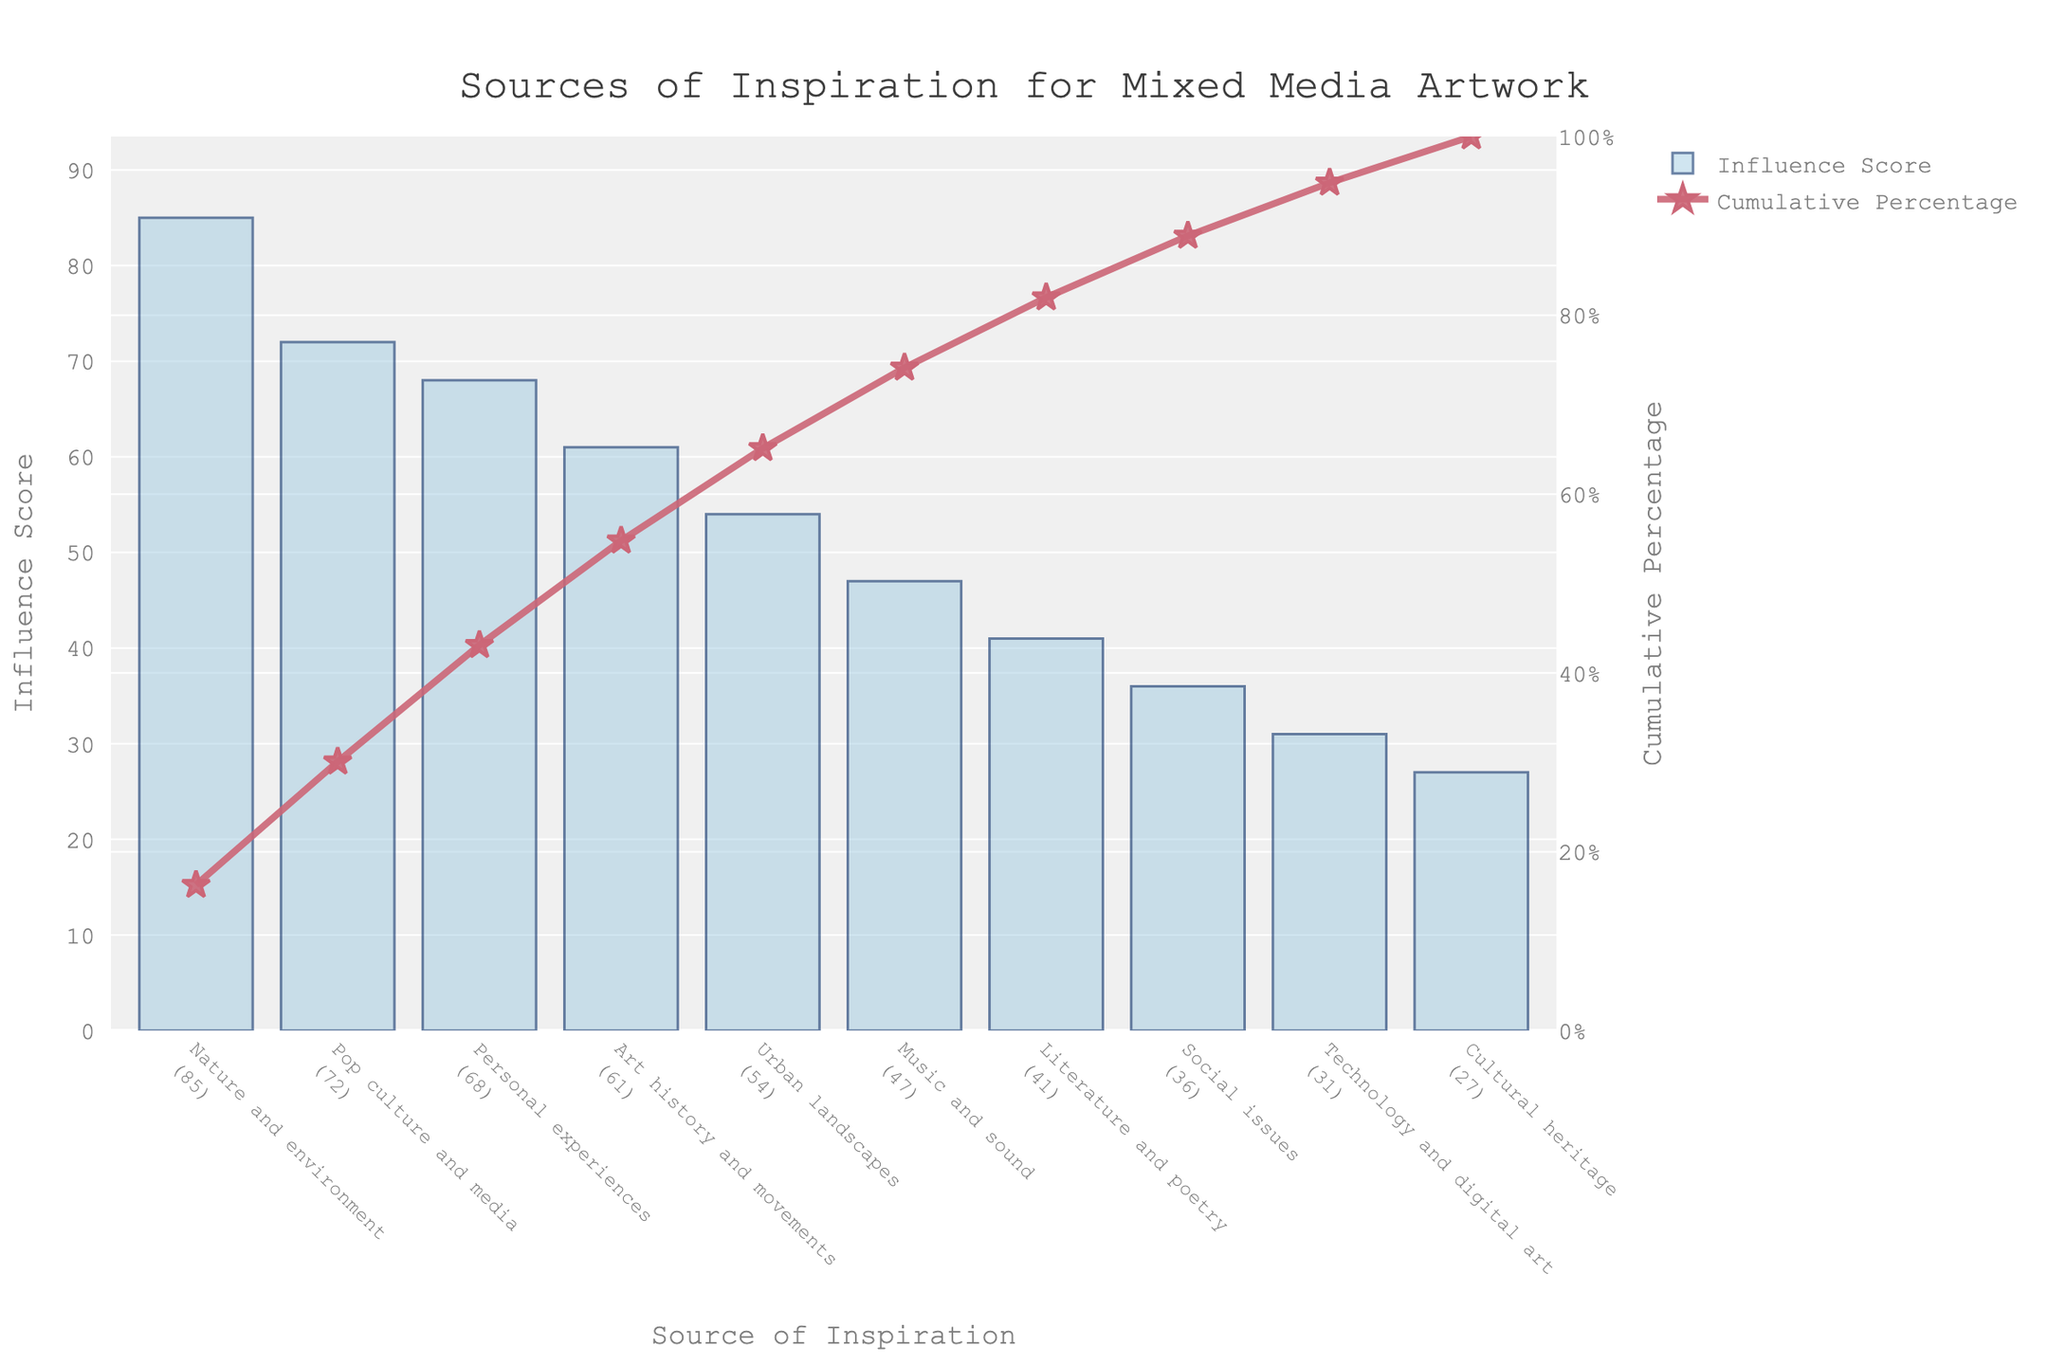What's the title of the chart? The title is prominently displayed at the top of the chart, typically in a larger font size. It reads "Sources of Inspiration for Mixed Media Artwork."
Answer: Sources of Inspiration for Mixed Media Artwork Which source of inspiration has the highest influence score? By looking at the heights of the bars, the tallest bar represents the source with the highest influence score. It is labeled "Nature and environment."
Answer: Nature and environment How many sources of inspiration have an influence score above 60? Looking at the bars, identify and count those with an influence score higher than 60. "Nature and environment," "Pop culture and media," "Personal experiences," and "Art history and movements" are above 60.
Answer: 4 What is the cumulative percentage for the top 3 sources of inspiration? Refer to the cumulative percentage line and sum the values for the top three sources: "Nature and environment" (35.2%), "Pop culture and media" (65.5%), and "Personal experiences" (89%).
Answer: 89% Which source of inspiration has the lowest influence score? The shortest bar represents the source with the lowest influence score. It is labeled "Cultural heritage."
Answer: Cultural heritage What's the influence score difference between the highest and the lowest sources of inspiration? Subtract the influence score of the lowest source from that of the highest. The highest is "Nature and environment" (85) and the lowest is "Cultural heritage" (27). So, 85 - 27 = 58.
Answer: 58 Among "Urban landscapes" and "Technology and digital art," which has a higher influence score, and by how much? Compare the heights of the bars for "Urban landscapes" and "Technology and digital art." "Urban landscapes" has 54 and "Technology and digital art" has 31. So the difference is 54 - 31 = 23.
Answer: Urban landscapes by 23 What is the cumulative percentage of sources contributing to 80% of the total influence score? The cumulative percentage line graph aids in this. Identify the sources up to the point where the cumulative percentage crosses 80%. This includes "Nature and environment," "Pop culture and media," "Personal experiences," "Art history and movements," and "Urban landscapes" (88.4%).
Answer: 88.4% How do the influence scores of "Music and sound" and "Social issues" compare? Look at the heights of the bars for each source. "Music and sound" has an influence score of 47, whereas "Social issues" has 36.
Answer: Music and sound has a higher score What is the color of the cumulative percentage line and the marker shape used? The cumulative percentage line is a distinct color and has specific markers. It is a pinkish-red color, and the markers are star-shaped.
Answer: Pinkish-red line with star markers 